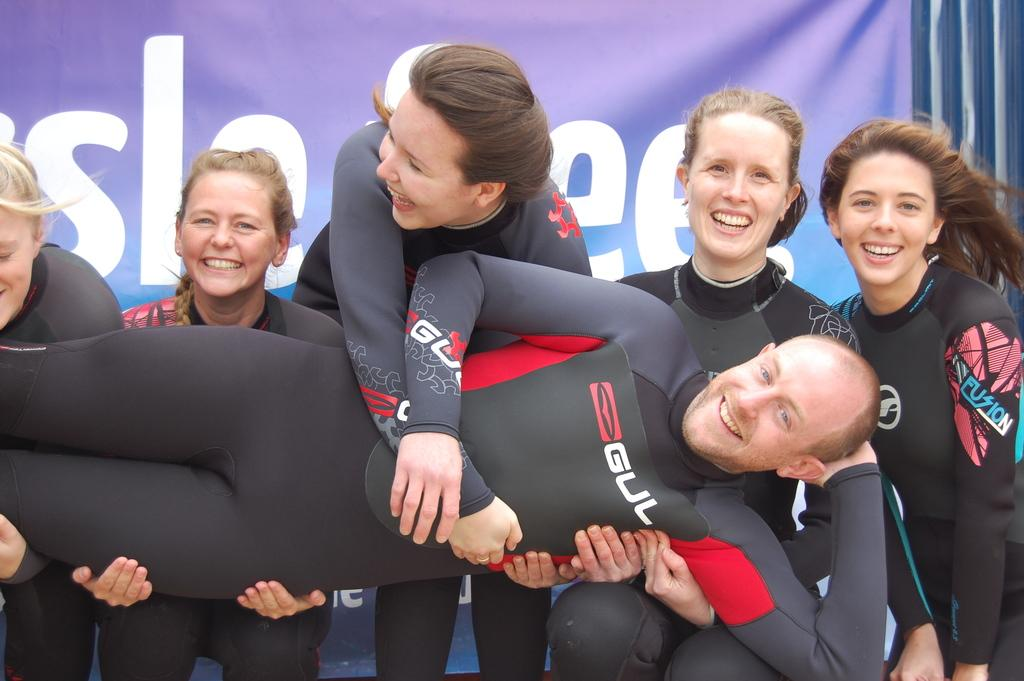How many people are in the image? There are people in the image, but the exact number is not specified. Where are the people located in the image? The people are standing in the center of the image. What are the people doing in the image? They are holding one person. What can be inferred about the people's emotions from their facial expressions? The people are smiling, as seen on their faces. What type of hook can be seen in the image? There is no hook present in the image. What historical event is depicted in the image? The image does not depict any specific historical event. 